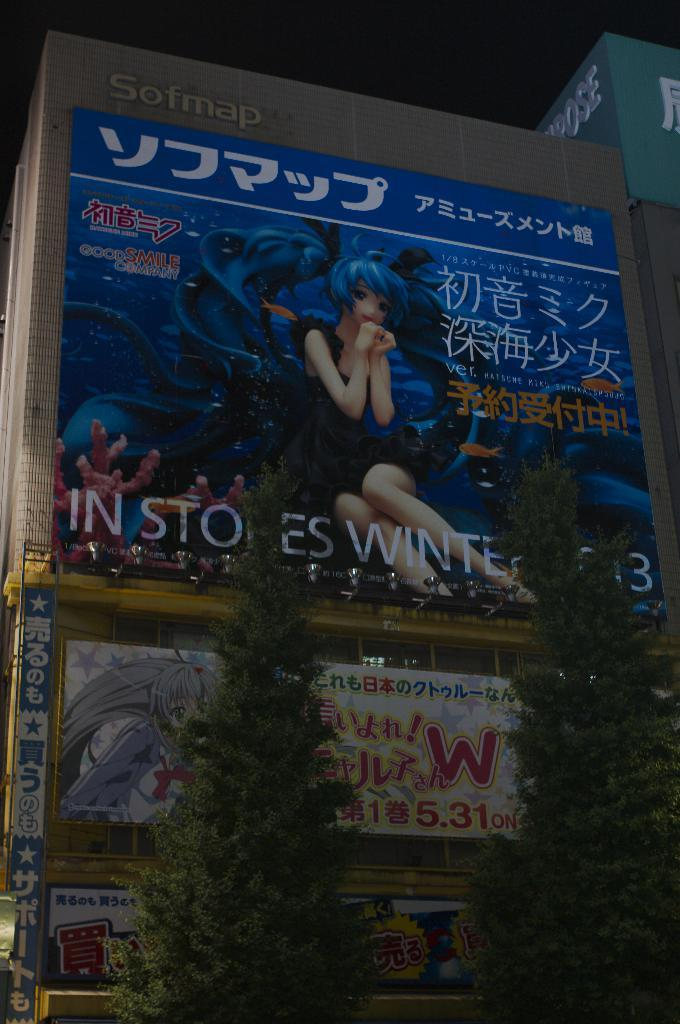<image>
Give a short and clear explanation of the subsequent image. The Softmap building has several banners hanging from it, including one that says in stores winter 2013. 